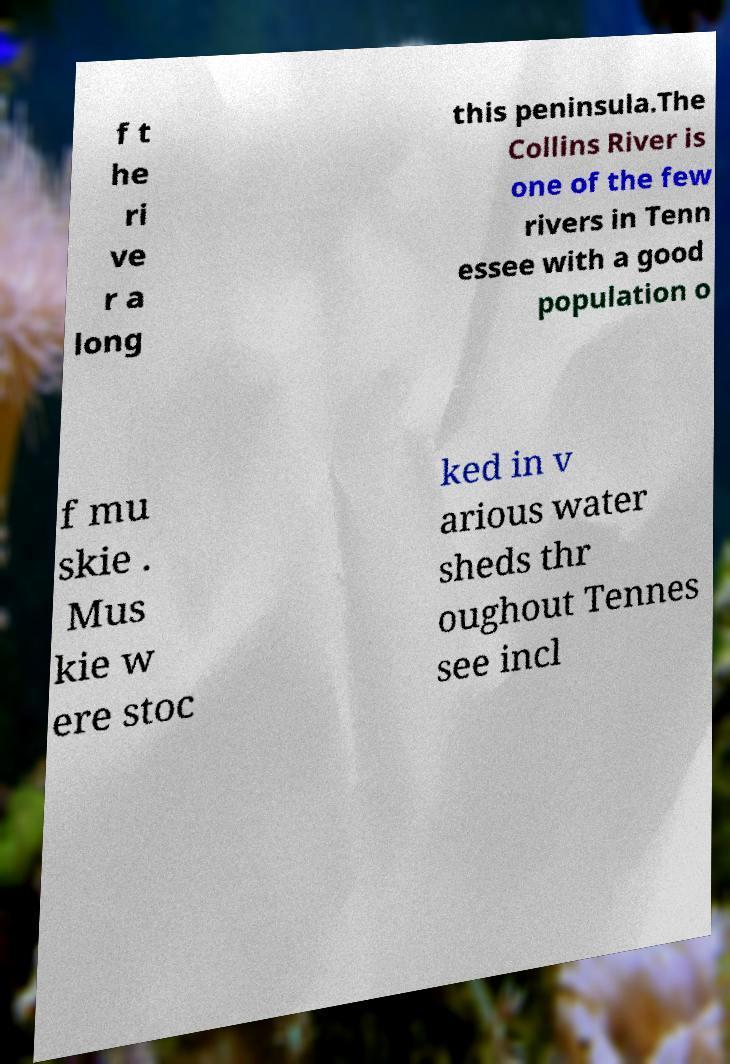Can you accurately transcribe the text from the provided image for me? f t he ri ve r a long this peninsula.The Collins River is one of the few rivers in Tenn essee with a good population o f mu skie . Mus kie w ere stoc ked in v arious water sheds thr oughout Tennes see incl 